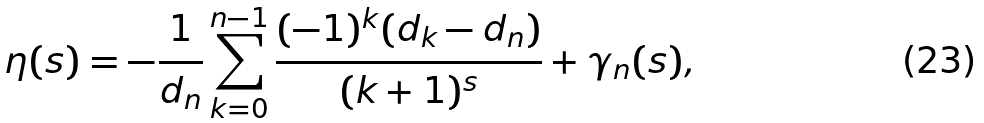<formula> <loc_0><loc_0><loc_500><loc_500>\eta ( s ) = - { \frac { 1 } { d _ { n } } } \sum _ { k = 0 } ^ { n - 1 } { \frac { ( - 1 ) ^ { k } ( d _ { k } - d _ { n } ) } { ( k + 1 ) ^ { s } } } + \gamma _ { n } ( s ) ,</formula> 